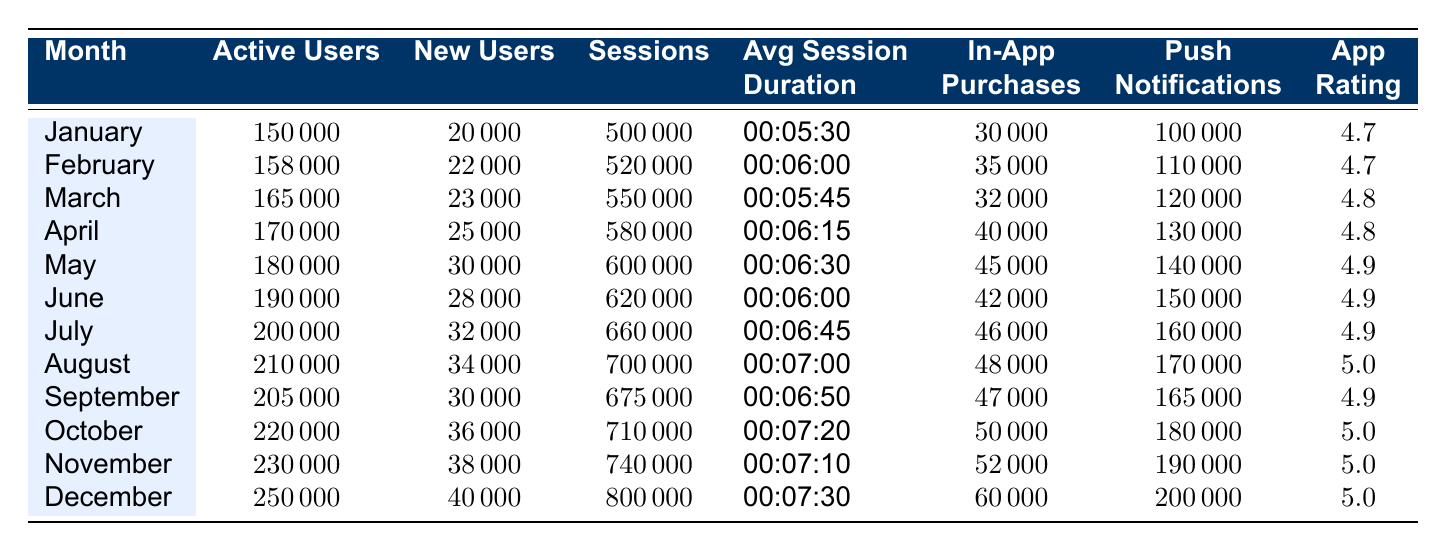What was the highest monthly app rating in 2023? The highest rating in the table is found in multiple months: August, October, November, and December, where the app rating is 5.0
Answer: 5.0 In which month did active users reach 220,000? According to the data, active users reached 220,000 in October
Answer: October What is the total number of in-app purchases made from January to March? Summing the in-app purchases for January (30,000), February (35,000), and March (32,000) gives us 30,000 + 35,000 + 32,000 = 97,000
Answer: 97,000 Did the number of new users increase from February to March? The new users in February are 22,000 and in March are 23,000. Since 23,000 is greater than 22,000, the number of new users did increase
Answer: Yes What was the average session duration in the first half of 2023 (January to June)? First, convert the session durations into seconds: January (330), February (360), March (345), April (375), May (390), June (360). The sum is 330 + 360 + 345 + 375 + 390 + 360 = 2160 seconds. Dividing by 6 gives an average of 360 seconds, which converts back to 00:06:00
Answer: 00:06:00 What was the percentage increase in sessions from January to December? The sessions in January are 500,000 and in December are 800,000. The increase is 800,000 - 500,000 = 300,000. The percentage increase is (300,000 / 500,000) * 100 = 60%
Answer: 60% Which month had the highest number of new users and what was the count? December had the highest number of new users at 40,000, as shown in the table
Answer: 40,000 Is the average session duration in July longer than in June? The average session duration in July is 00:06:45, while in June it is 00:06:00. Since 00:06:45 is greater than 00:06:00, the average session duration is longer
Answer: Yes How many push notifications were sent in total for the months of April and May? For April, 130,000 notifications were sent, and for May, 140,000. So, the total is 130,000 + 140,000 = 270,000
Answer: 270,000 Did the number of active users in August exceed that in February? The active users in February is 158,000 and in August is 210,000. Since 210,000 is greater than 158,000, the answer is yes
Answer: Yes What was the monthly average of sessions reached between the months of October and December? The sessions in October, November, and December are 710,000, 740,000, and 800,000 respectively. The average is (710,000 + 740,000 + 800,000) / 3 = 750,000
Answer: 750,000 